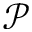Convert formula to latex. <formula><loc_0><loc_0><loc_500><loc_500>\mathcal { P }</formula> 